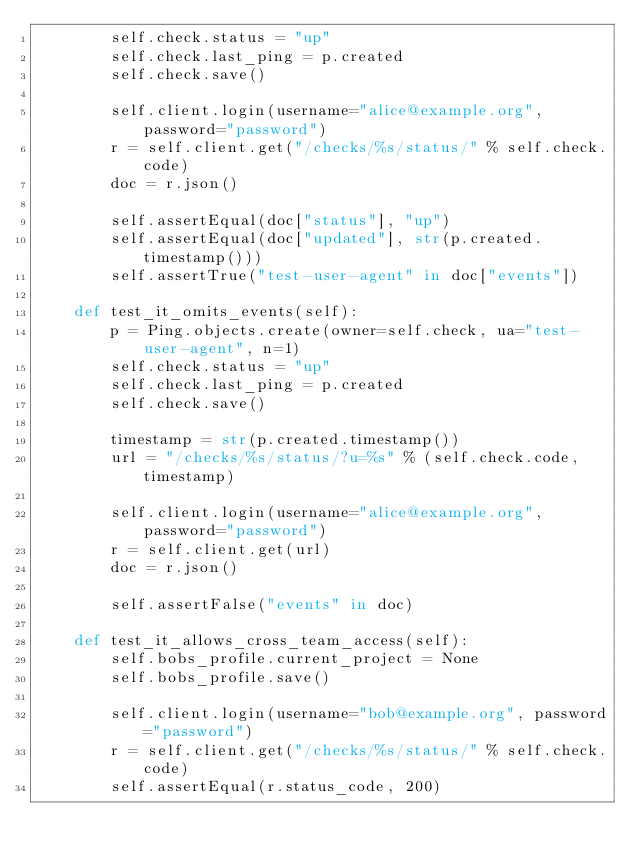Convert code to text. <code><loc_0><loc_0><loc_500><loc_500><_Python_>        self.check.status = "up"
        self.check.last_ping = p.created
        self.check.save()

        self.client.login(username="alice@example.org", password="password")
        r = self.client.get("/checks/%s/status/" % self.check.code)
        doc = r.json()

        self.assertEqual(doc["status"], "up")
        self.assertEqual(doc["updated"], str(p.created.timestamp()))
        self.assertTrue("test-user-agent" in doc["events"])

    def test_it_omits_events(self):
        p = Ping.objects.create(owner=self.check, ua="test-user-agent", n=1)
        self.check.status = "up"
        self.check.last_ping = p.created
        self.check.save()

        timestamp = str(p.created.timestamp())
        url = "/checks/%s/status/?u=%s" % (self.check.code, timestamp)

        self.client.login(username="alice@example.org", password="password")
        r = self.client.get(url)
        doc = r.json()

        self.assertFalse("events" in doc)

    def test_it_allows_cross_team_access(self):
        self.bobs_profile.current_project = None
        self.bobs_profile.save()

        self.client.login(username="bob@example.org", password="password")
        r = self.client.get("/checks/%s/status/" % self.check.code)
        self.assertEqual(r.status_code, 200)
</code> 